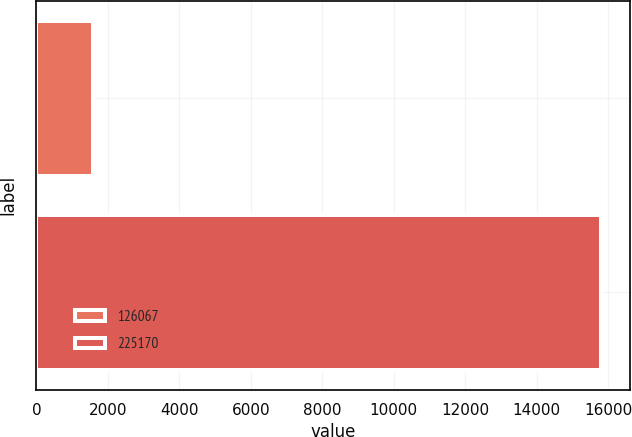Convert chart to OTSL. <chart><loc_0><loc_0><loc_500><loc_500><bar_chart><fcel>126067<fcel>225170<nl><fcel>1575<fcel>15817<nl></chart> 